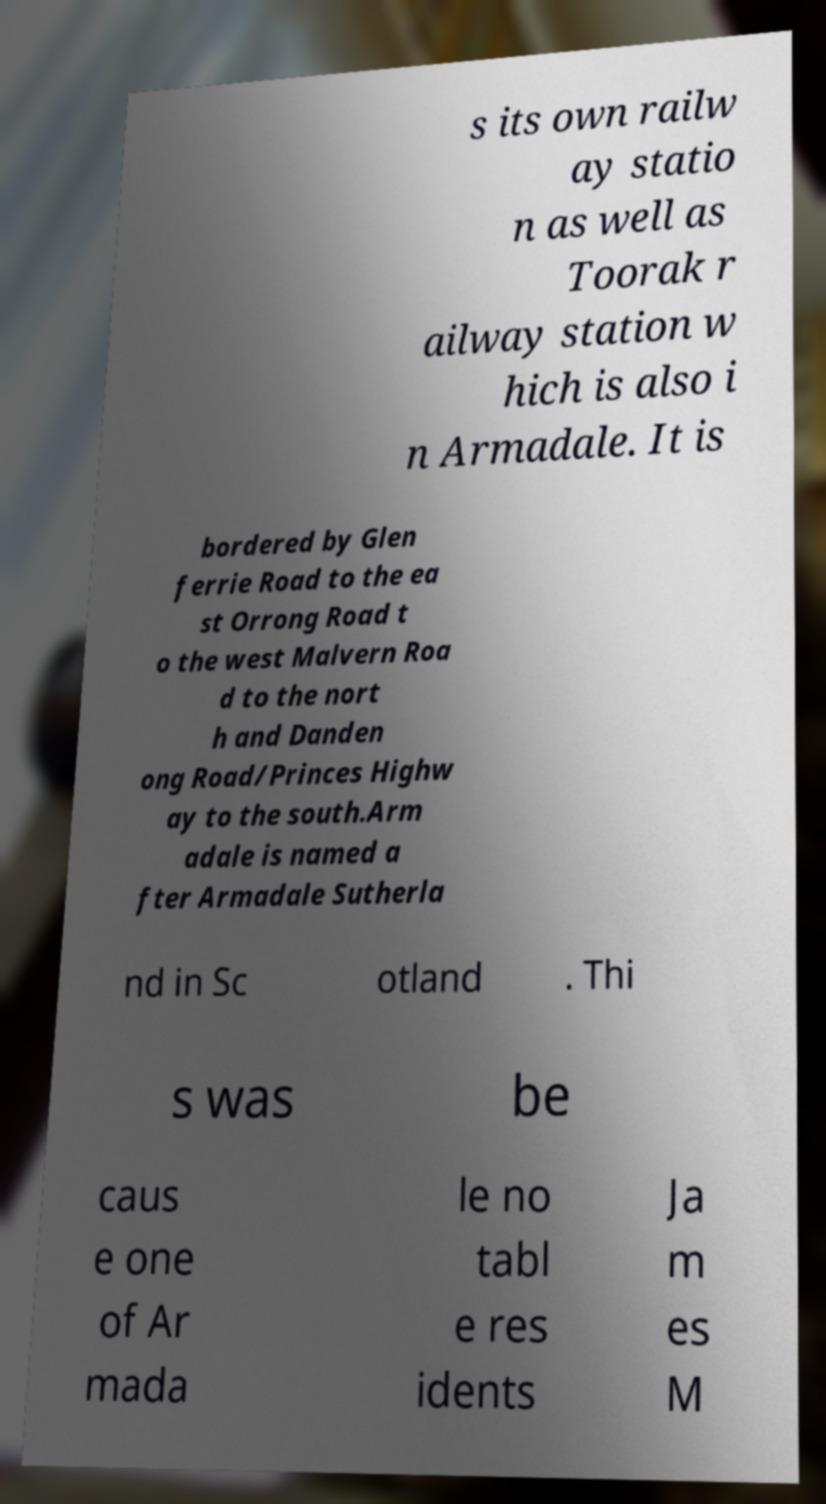Can you read and provide the text displayed in the image?This photo seems to have some interesting text. Can you extract and type it out for me? s its own railw ay statio n as well as Toorak r ailway station w hich is also i n Armadale. It is bordered by Glen ferrie Road to the ea st Orrong Road t o the west Malvern Roa d to the nort h and Danden ong Road/Princes Highw ay to the south.Arm adale is named a fter Armadale Sutherla nd in Sc otland . Thi s was be caus e one of Ar mada le no tabl e res idents Ja m es M 